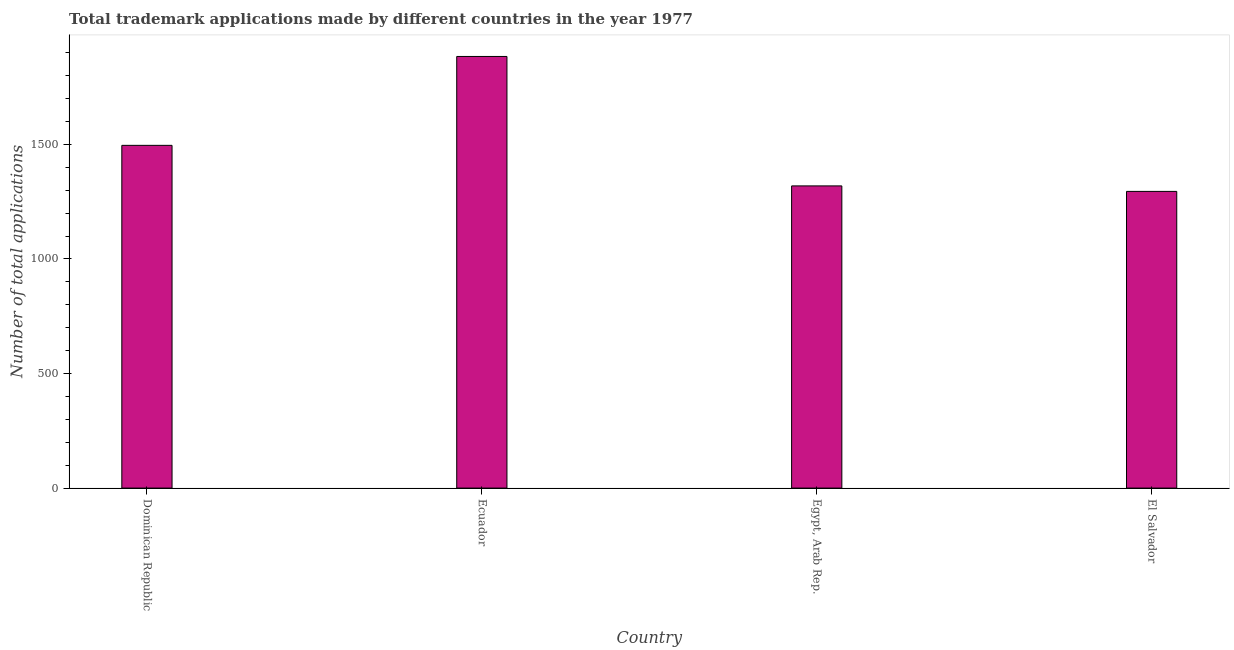Does the graph contain any zero values?
Offer a very short reply. No. What is the title of the graph?
Your response must be concise. Total trademark applications made by different countries in the year 1977. What is the label or title of the Y-axis?
Your response must be concise. Number of total applications. What is the number of trademark applications in Ecuador?
Provide a short and direct response. 1884. Across all countries, what is the maximum number of trademark applications?
Keep it short and to the point. 1884. Across all countries, what is the minimum number of trademark applications?
Ensure brevity in your answer.  1295. In which country was the number of trademark applications maximum?
Provide a succinct answer. Ecuador. In which country was the number of trademark applications minimum?
Your answer should be compact. El Salvador. What is the sum of the number of trademark applications?
Keep it short and to the point. 5994. What is the difference between the number of trademark applications in Ecuador and El Salvador?
Ensure brevity in your answer.  589. What is the average number of trademark applications per country?
Keep it short and to the point. 1498. What is the median number of trademark applications?
Ensure brevity in your answer.  1407.5. What is the ratio of the number of trademark applications in Ecuador to that in El Salvador?
Your answer should be compact. 1.46. Is the difference between the number of trademark applications in Dominican Republic and Ecuador greater than the difference between any two countries?
Offer a very short reply. No. What is the difference between the highest and the second highest number of trademark applications?
Make the answer very short. 388. Is the sum of the number of trademark applications in Ecuador and El Salvador greater than the maximum number of trademark applications across all countries?
Your response must be concise. Yes. What is the difference between the highest and the lowest number of trademark applications?
Give a very brief answer. 589. Are all the bars in the graph horizontal?
Your answer should be very brief. No. How many countries are there in the graph?
Keep it short and to the point. 4. Are the values on the major ticks of Y-axis written in scientific E-notation?
Provide a short and direct response. No. What is the Number of total applications in Dominican Republic?
Offer a very short reply. 1496. What is the Number of total applications in Ecuador?
Give a very brief answer. 1884. What is the Number of total applications in Egypt, Arab Rep.?
Ensure brevity in your answer.  1319. What is the Number of total applications of El Salvador?
Provide a succinct answer. 1295. What is the difference between the Number of total applications in Dominican Republic and Ecuador?
Give a very brief answer. -388. What is the difference between the Number of total applications in Dominican Republic and Egypt, Arab Rep.?
Offer a very short reply. 177. What is the difference between the Number of total applications in Dominican Republic and El Salvador?
Offer a terse response. 201. What is the difference between the Number of total applications in Ecuador and Egypt, Arab Rep.?
Keep it short and to the point. 565. What is the difference between the Number of total applications in Ecuador and El Salvador?
Offer a very short reply. 589. What is the ratio of the Number of total applications in Dominican Republic to that in Ecuador?
Provide a short and direct response. 0.79. What is the ratio of the Number of total applications in Dominican Republic to that in Egypt, Arab Rep.?
Offer a terse response. 1.13. What is the ratio of the Number of total applications in Dominican Republic to that in El Salvador?
Provide a succinct answer. 1.16. What is the ratio of the Number of total applications in Ecuador to that in Egypt, Arab Rep.?
Your response must be concise. 1.43. What is the ratio of the Number of total applications in Ecuador to that in El Salvador?
Give a very brief answer. 1.46. 